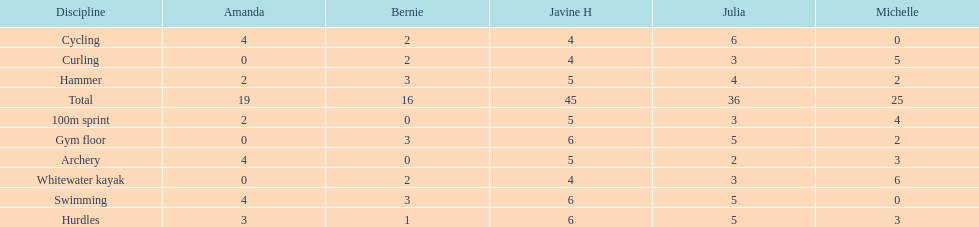Who earned the most total points? Javine H. 